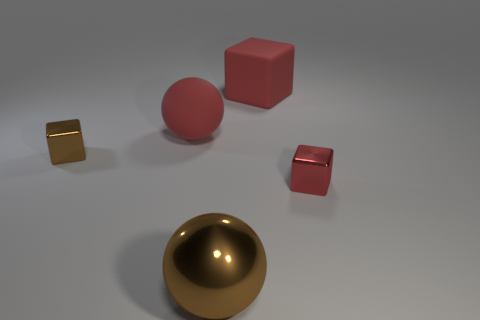Subtract all red blocks. How many were subtracted if there are1red blocks left? 1 Add 3 small metal objects. How many objects exist? 8 Subtract all tiny blocks. How many blocks are left? 1 Subtract all balls. How many objects are left? 3 Subtract all small brown metallic cubes. Subtract all small brown metal objects. How many objects are left? 3 Add 3 brown metal cubes. How many brown metal cubes are left? 4 Add 3 blue shiny objects. How many blue shiny objects exist? 3 Subtract 0 blue cylinders. How many objects are left? 5 